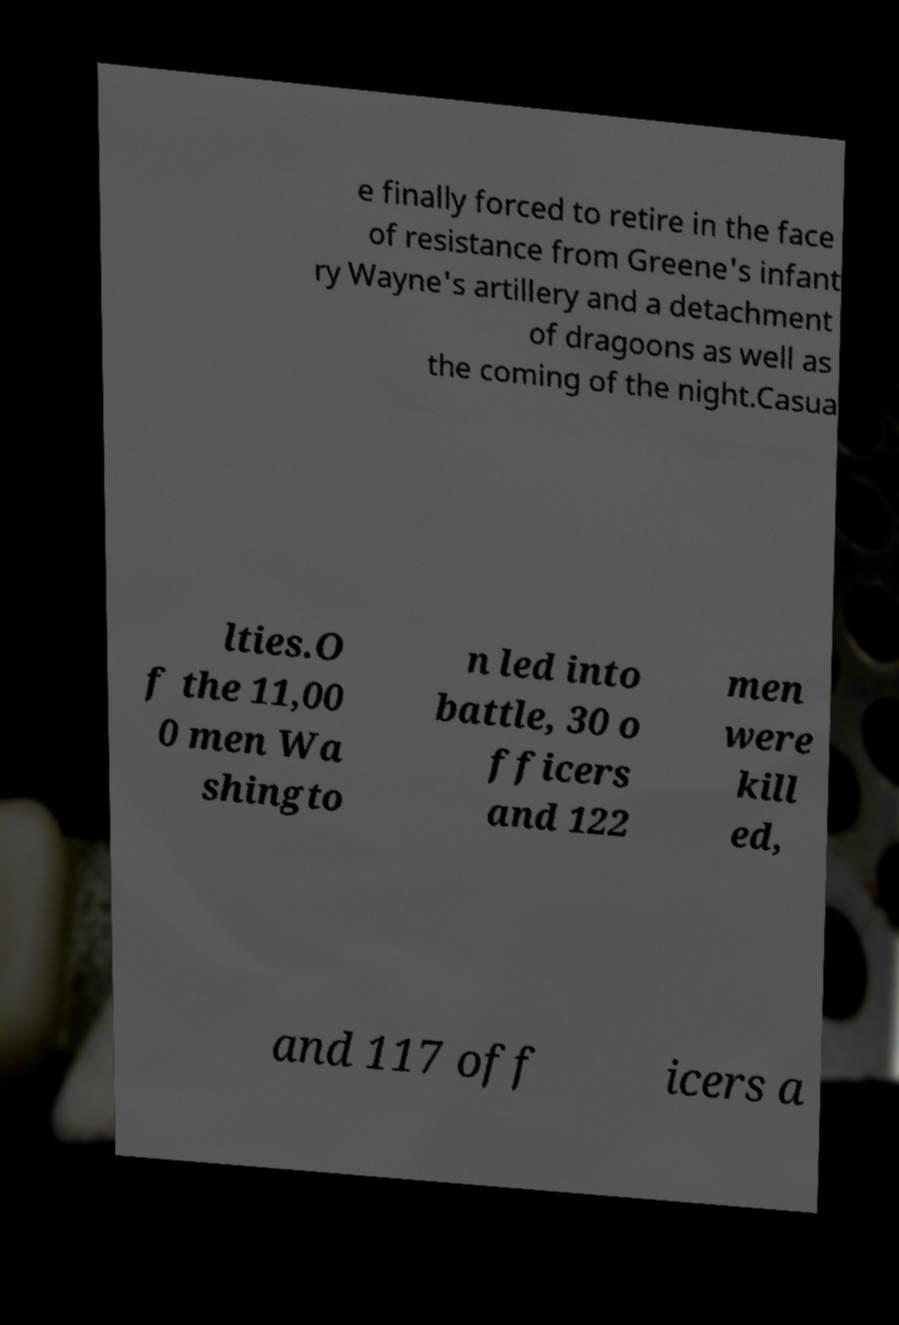Can you read and provide the text displayed in the image?This photo seems to have some interesting text. Can you extract and type it out for me? e finally forced to retire in the face of resistance from Greene's infant ry Wayne's artillery and a detachment of dragoons as well as the coming of the night.Casua lties.O f the 11,00 0 men Wa shingto n led into battle, 30 o fficers and 122 men were kill ed, and 117 off icers a 